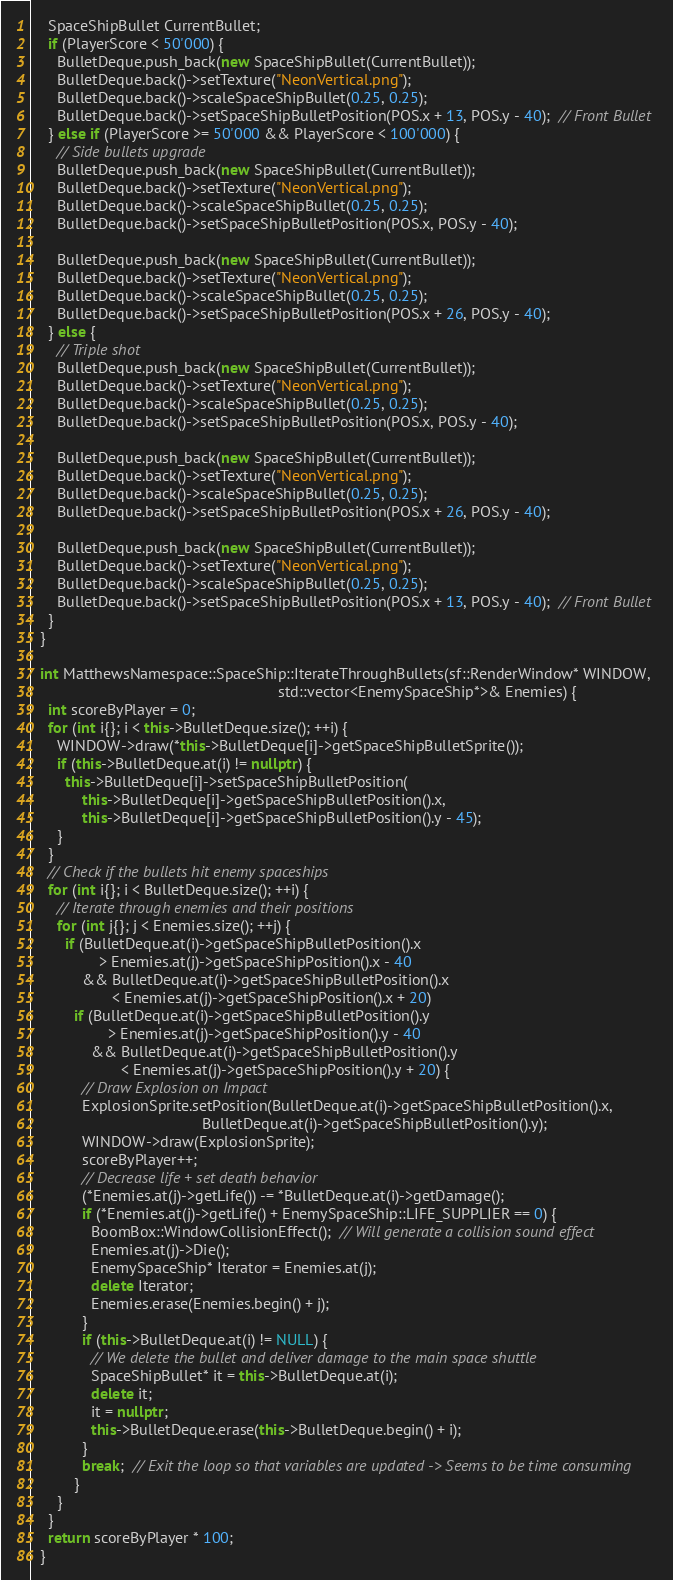Convert code to text. <code><loc_0><loc_0><loc_500><loc_500><_C++_>    SpaceShipBullet CurrentBullet;
    if (PlayerScore < 50'000) {
      BulletDeque.push_back(new SpaceShipBullet(CurrentBullet));
      BulletDeque.back()->setTexture("NeonVertical.png");
      BulletDeque.back()->scaleSpaceShipBullet(0.25, 0.25);
      BulletDeque.back()->setSpaceShipBulletPosition(POS.x + 13, POS.y - 40);  // Front Bullet
    } else if (PlayerScore >= 50'000 && PlayerScore < 100'000) {
      // Side bullets upgrade
      BulletDeque.push_back(new SpaceShipBullet(CurrentBullet));
      BulletDeque.back()->setTexture("NeonVertical.png");
      BulletDeque.back()->scaleSpaceShipBullet(0.25, 0.25);
      BulletDeque.back()->setSpaceShipBulletPosition(POS.x, POS.y - 40);

      BulletDeque.push_back(new SpaceShipBullet(CurrentBullet));
      BulletDeque.back()->setTexture("NeonVertical.png");
      BulletDeque.back()->scaleSpaceShipBullet(0.25, 0.25);
      BulletDeque.back()->setSpaceShipBulletPosition(POS.x + 26, POS.y - 40);
    } else {
      // Triple shot
      BulletDeque.push_back(new SpaceShipBullet(CurrentBullet));
      BulletDeque.back()->setTexture("NeonVertical.png");
      BulletDeque.back()->scaleSpaceShipBullet(0.25, 0.25);
      BulletDeque.back()->setSpaceShipBulletPosition(POS.x, POS.y - 40);

      BulletDeque.push_back(new SpaceShipBullet(CurrentBullet));
      BulletDeque.back()->setTexture("NeonVertical.png");
      BulletDeque.back()->scaleSpaceShipBullet(0.25, 0.25);
      BulletDeque.back()->setSpaceShipBulletPosition(POS.x + 26, POS.y - 40);

      BulletDeque.push_back(new SpaceShipBullet(CurrentBullet));
      BulletDeque.back()->setTexture("NeonVertical.png");
      BulletDeque.back()->scaleSpaceShipBullet(0.25, 0.25);
      BulletDeque.back()->setSpaceShipBulletPosition(POS.x + 13, POS.y - 40);  // Front Bullet
    }
  }

  int MatthewsNamespace::SpaceShip::IterateThroughBullets(sf::RenderWindow* WINDOW,
                                                          std::vector<EnemySpaceShip*>& Enemies) {
    int scoreByPlayer = 0;
    for (int i{}; i < this->BulletDeque.size(); ++i) {
      WINDOW->draw(*this->BulletDeque[i]->getSpaceShipBulletSprite());
      if (this->BulletDeque.at(i) != nullptr) {
        this->BulletDeque[i]->setSpaceShipBulletPosition(
            this->BulletDeque[i]->getSpaceShipBulletPosition().x,
            this->BulletDeque[i]->getSpaceShipBulletPosition().y - 45);
      }
    }
    // Check if the bullets hit enemy spaceships
    for (int i{}; i < BulletDeque.size(); ++i) {
      // Iterate through enemies and their positions
      for (int j{}; j < Enemies.size(); ++j) {
        if (BulletDeque.at(i)->getSpaceShipBulletPosition().x
                > Enemies.at(j)->getSpaceShipPosition().x - 40
            && BulletDeque.at(i)->getSpaceShipBulletPosition().x
                   < Enemies.at(j)->getSpaceShipPosition().x + 20)
          if (BulletDeque.at(i)->getSpaceShipBulletPosition().y
                  > Enemies.at(j)->getSpaceShipPosition().y - 40
              && BulletDeque.at(i)->getSpaceShipBulletPosition().y
                     < Enemies.at(j)->getSpaceShipPosition().y + 20) {
            // Draw Explosion on Impact
            ExplosionSprite.setPosition(BulletDeque.at(i)->getSpaceShipBulletPosition().x,
                                        BulletDeque.at(i)->getSpaceShipBulletPosition().y);
            WINDOW->draw(ExplosionSprite);
            scoreByPlayer++;
            // Decrease life + set death behavior
            (*Enemies.at(j)->getLife()) -= *BulletDeque.at(i)->getDamage();
            if (*Enemies.at(j)->getLife() + EnemySpaceShip::LIFE_SUPPLIER == 0) {
              BoomBox::WindowCollisionEffect();  // Will generate a collision sound effect
              Enemies.at(j)->Die();
              EnemySpaceShip* Iterator = Enemies.at(j);
              delete Iterator;
              Enemies.erase(Enemies.begin() + j);
            }
            if (this->BulletDeque.at(i) != NULL) {
              // We delete the bullet and deliver damage to the main space shuttle
              SpaceShipBullet* it = this->BulletDeque.at(i);
              delete it;
              it = nullptr;
              this->BulletDeque.erase(this->BulletDeque.begin() + i);
            }
            break;  // Exit the loop so that variables are updated -> Seems to be time consuming
          }
      }
    }
    return scoreByPlayer * 100;
  }</code> 